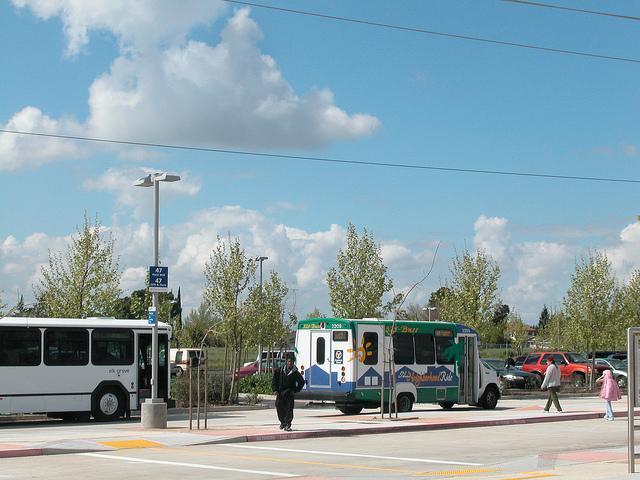How many people can be seen?
Give a very brief answer. 3. How many power lines?
Give a very brief answer. 3. How many buses are there?
Give a very brief answer. 2. 